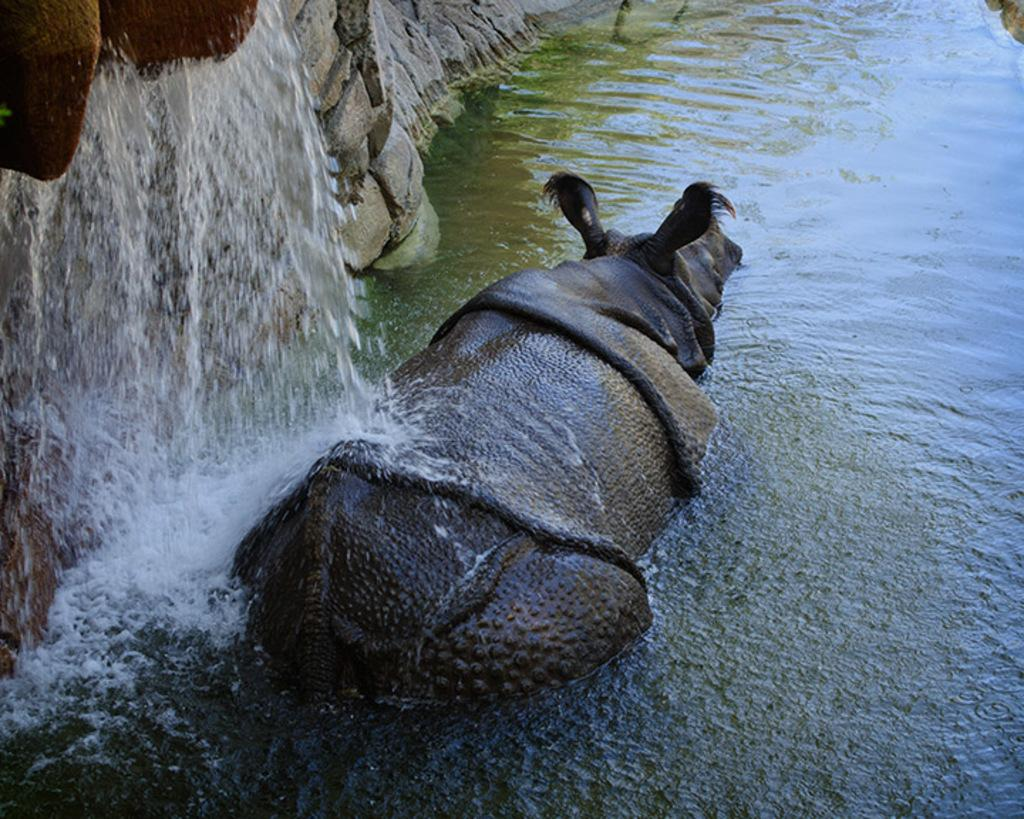What is on the surface of the water in the image? There is an animal on the surface of the water in the image. What is happening to the animal in the image? Water is falling on the animal in the image. How much money is the animal holding in the image? There is no money present in the image; it only features an animal on the water with water falling on it. 